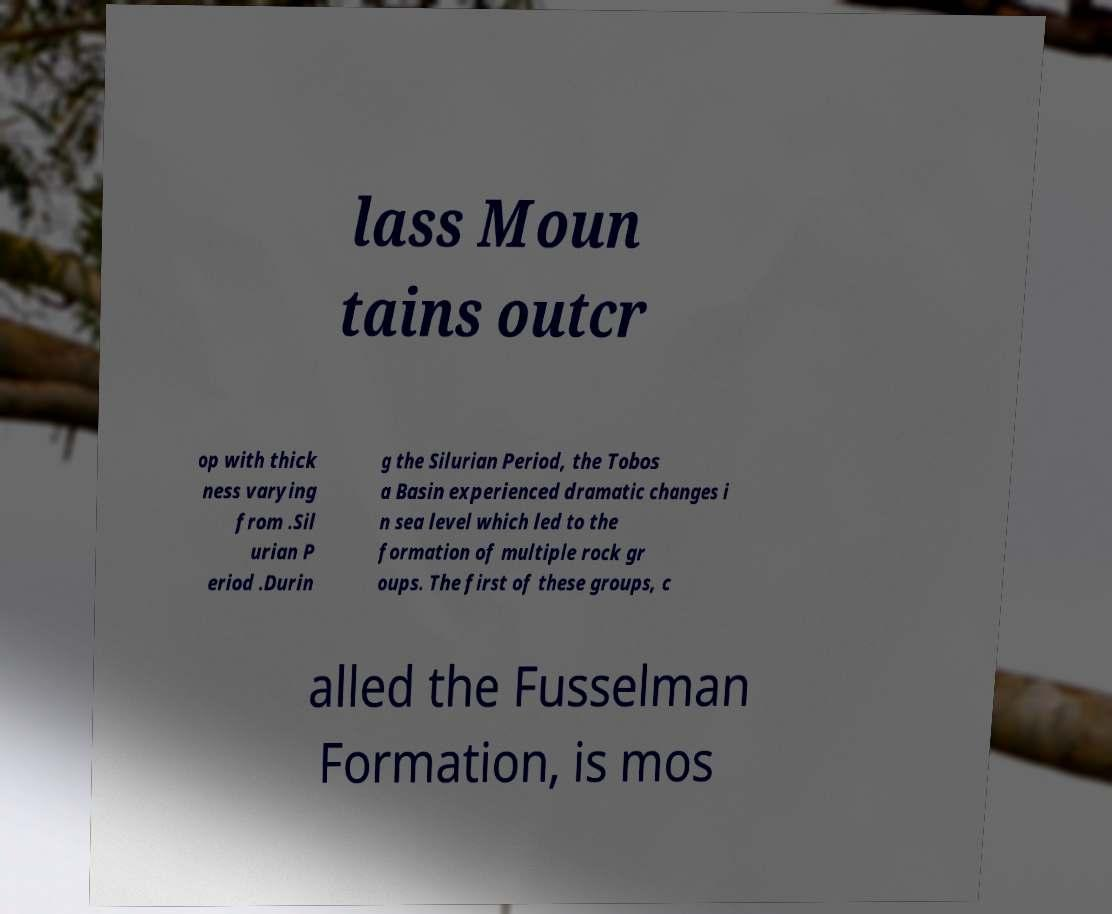Could you extract and type out the text from this image? lass Moun tains outcr op with thick ness varying from .Sil urian P eriod .Durin g the Silurian Period, the Tobos a Basin experienced dramatic changes i n sea level which led to the formation of multiple rock gr oups. The first of these groups, c alled the Fusselman Formation, is mos 